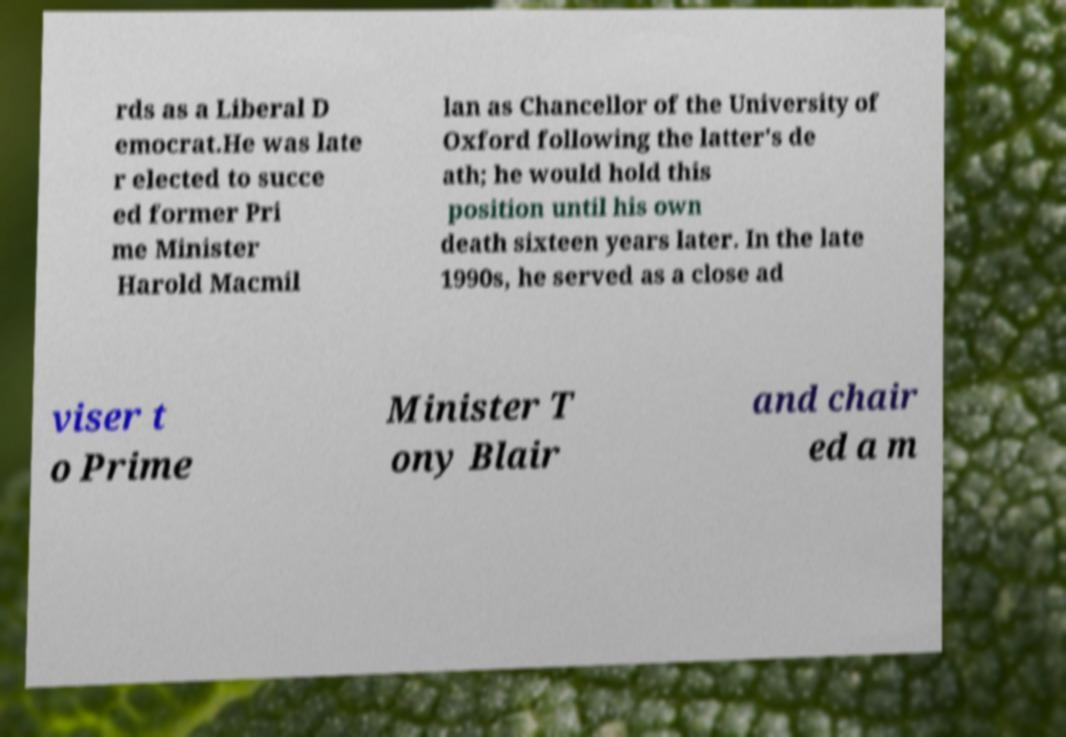Could you extract and type out the text from this image? rds as a Liberal D emocrat.He was late r elected to succe ed former Pri me Minister Harold Macmil lan as Chancellor of the University of Oxford following the latter's de ath; he would hold this position until his own death sixteen years later. In the late 1990s, he served as a close ad viser t o Prime Minister T ony Blair and chair ed a m 